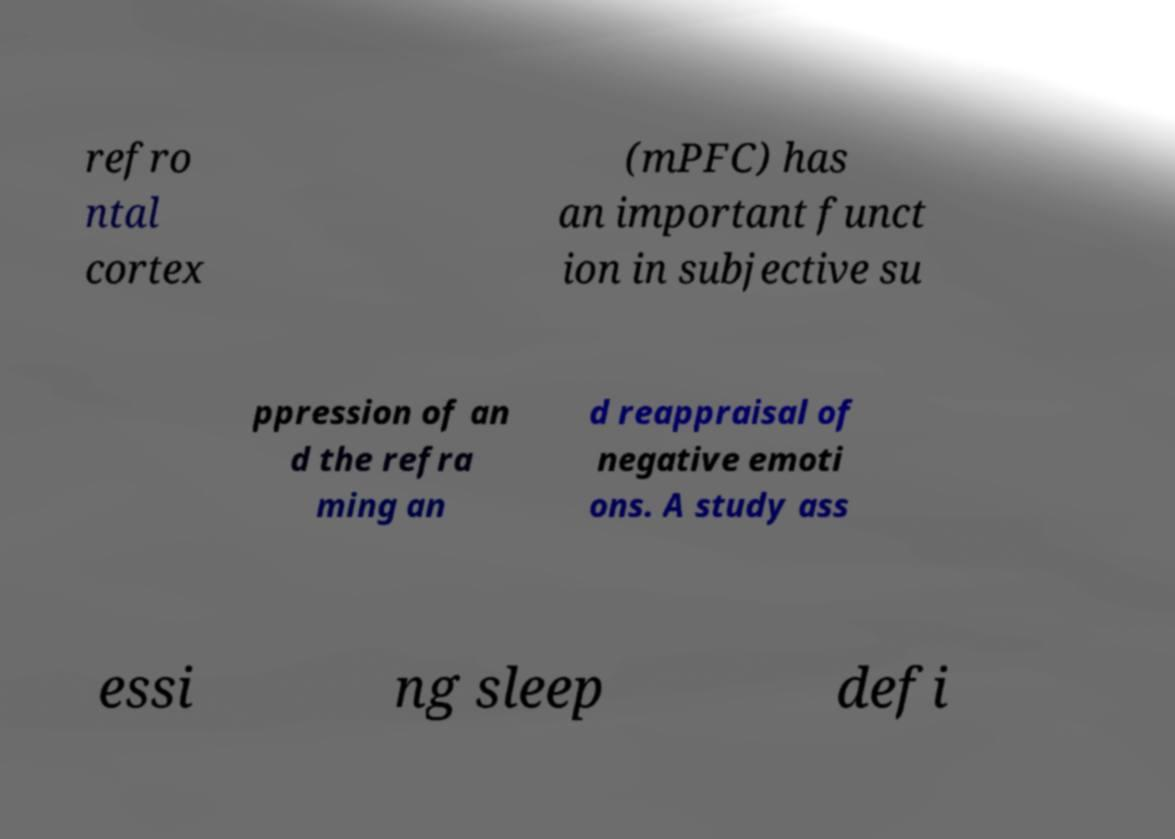Could you extract and type out the text from this image? refro ntal cortex (mPFC) has an important funct ion in subjective su ppression of an d the refra ming an d reappraisal of negative emoti ons. A study ass essi ng sleep defi 